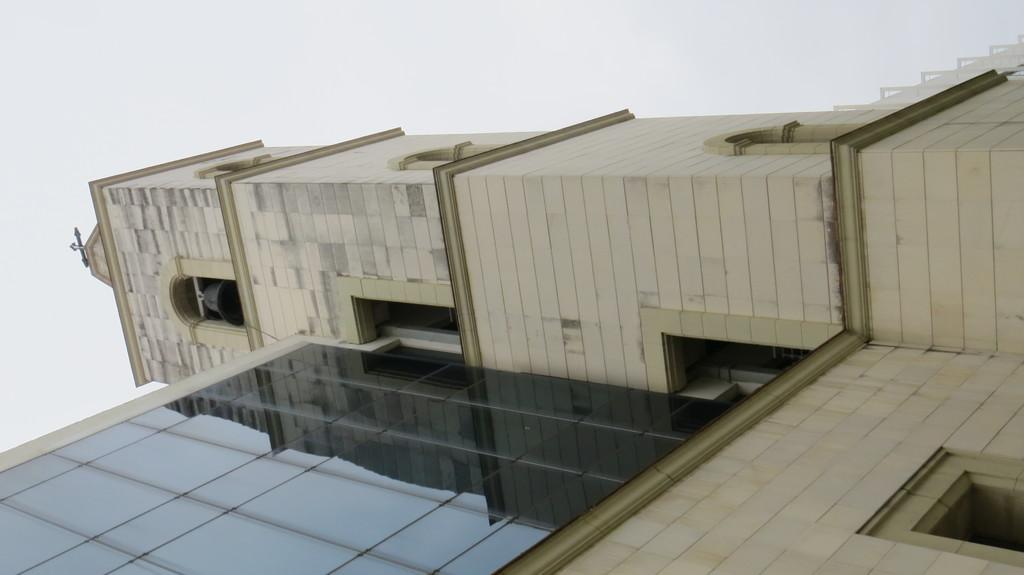What type of building is in the image? There is a church in the image. What can be seen on the left side of the church? There is a bell on the left side of the church. What religious symbol is present in the image? There is a cross mark in the image. What is visible at the top of the image? The sky is visible at the top of the image. What can be observed in the sky? Clouds are present in the sky. Who is the owner of the cabbage in the image? There is no cabbage present in the image. What part of the church is shown in the image? The image shows the entire church, not just a part of it. 